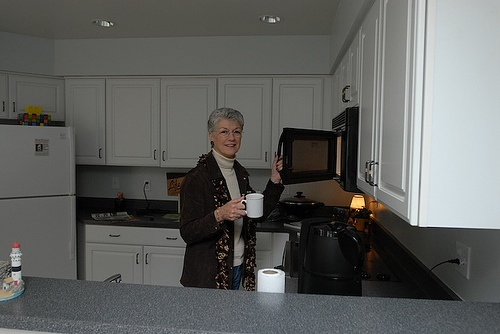Describe the objects in this image and their specific colors. I can see people in gray, black, and darkgray tones, refrigerator in gray, black, and darkgray tones, microwave in gray and black tones, and cup in gray, darkgray, black, and lightgray tones in this image. 